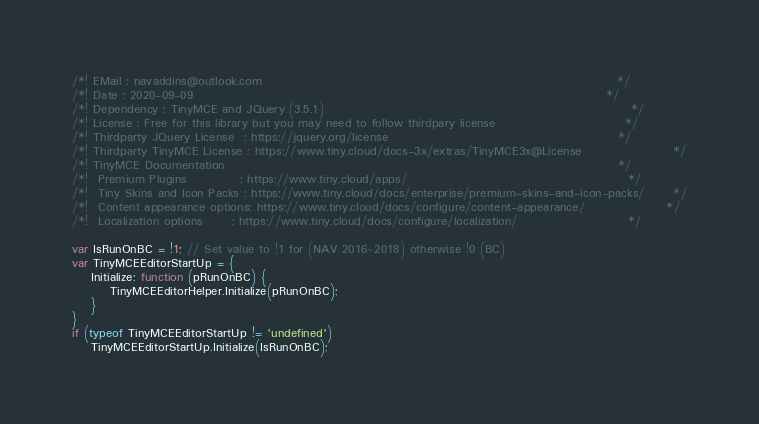<code> <loc_0><loc_0><loc_500><loc_500><_JavaScript_>/*! EMail : navaddins@outlook.com                                                                          */
/*! Date : 2020-09-09                                                                                      */
/*! Dependency : TinyMCE and JQuery (3.5.1)                                                                */
/*! License : Free for this library but you may need to follow thirdpary license                           */
/*! Thirdparty JQuery License  : https://jquery.org/license                                                */
/*! Thirdparty TinyMCE License : https://www.tiny.cloud/docs-3x/extras/TinyMCE3x@License                   */
/*! TinyMCE Documentation                                                                                  */
/*!  Premium Plugins           : https://www.tiny.cloud/apps/                                              */
/*!  Tiny Skins and Icon Packs : https://www.tiny.cloud/docs/enterprise/premium-skins-and-icon-packs/      */
/*!  Content appearance options: https://www.tiny.cloud/docs/configure/content-appearance/                 */
/*!  Localization options      : https://www.tiny.cloud/docs/configure/localization/                       */

var IsRunOnBC = !1; // Set value to !1 for (NAV 2016~2018) otherwise !0 (BC)
var TinyMCEEditorStartUp = {
    Initialize: function (pRunOnBC) {
        TinyMCEEditorHelper.Initialize(pRunOnBC);
    }
}
if (typeof TinyMCEEditorStartUp != 'undefined')
    TinyMCEEditorStartUp.Initialize(IsRunOnBC);</code> 